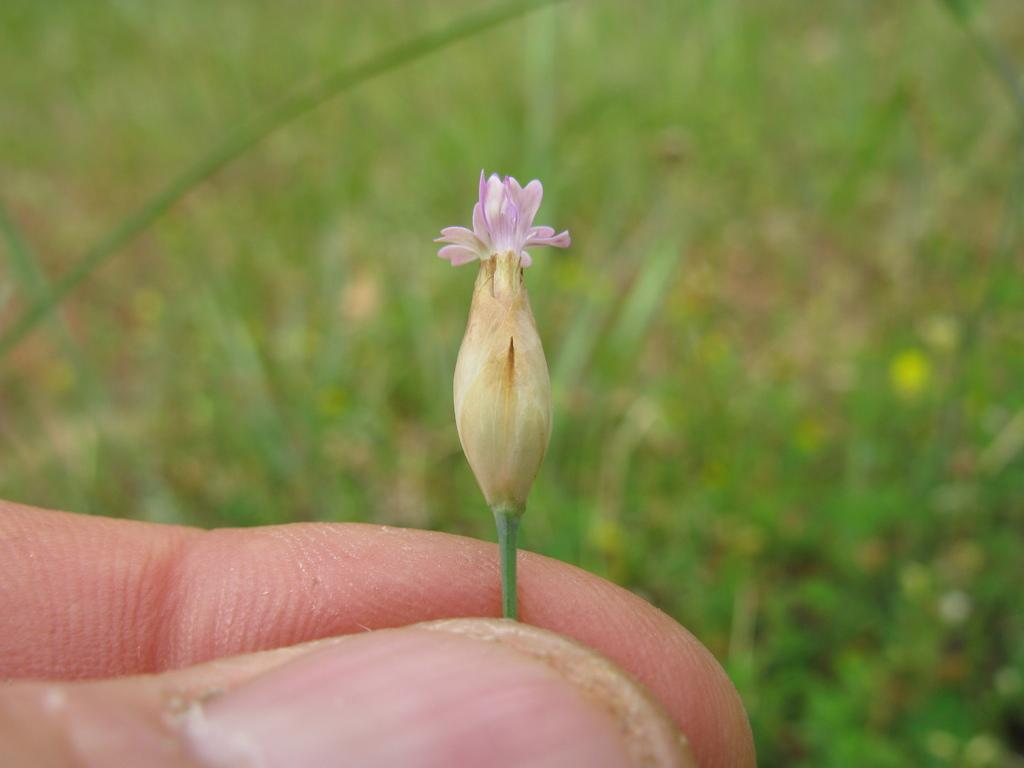Where was the image taken? The image was taken outdoors. What can be seen in the background of the image? There is a ground with grass in the background. What part of a person is visible in the image? A person's hand is visible at the bottom of the image. What is the hand holding? The hand is holding a little flower with two fingers. What type of music can be heard playing in the background of the image? There is no music present in the image, as it is a still photograph. 